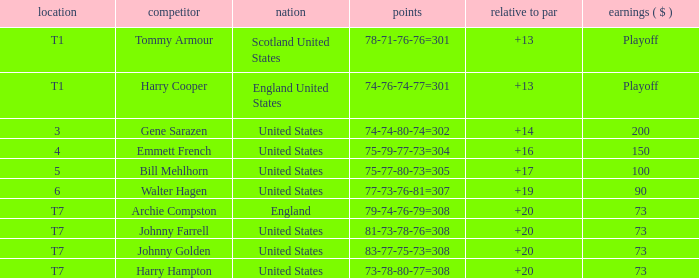Which country has a to par less than 19 and a score of 75-79-77-73=304? United States. 